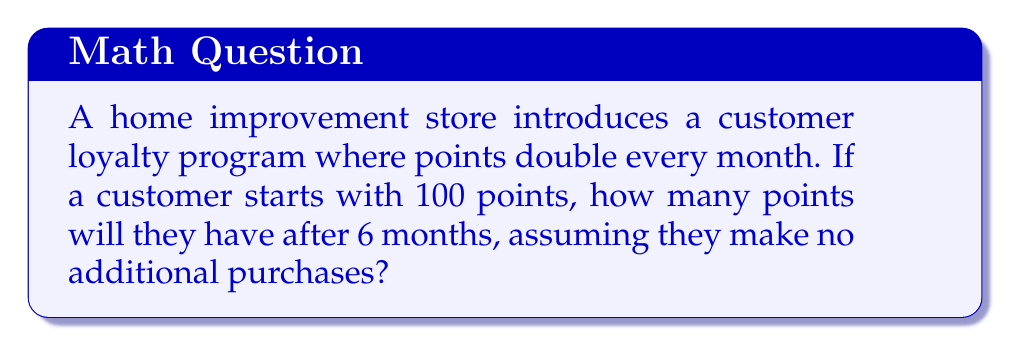Help me with this question. Let's approach this step-by-step:

1) We start with 100 points.
2) The points double every month, which means we multiply by 2 each time.
3) This happens for 6 months.

Mathematically, this can be represented as:

$$ 100 \cdot 2^6 $$

Let's calculate:

$$ 100 \cdot 2^6 = 100 \cdot 64 = 6400 $$

To break it down:
$$ 2^6 = 2 \cdot 2 \cdot 2 \cdot 2 \cdot 2 \cdot 2 = 64 $$

This is an example of exponential growth, where the growth factor is 2 and the number of periods is 6.

The general formula for exponential growth is:

$$ A = P(1 + r)^n $$

Where:
A = Final amount
P = Initial principal balance
r = Growth rate (100% or 1 in this case)
n = Number of time periods

In our case:
$$ A = 100(1 + 1)^6 = 100 \cdot 2^6 = 6400 $$

Therefore, after 6 months, the customer will have 6400 points.
Answer: 6400 points 